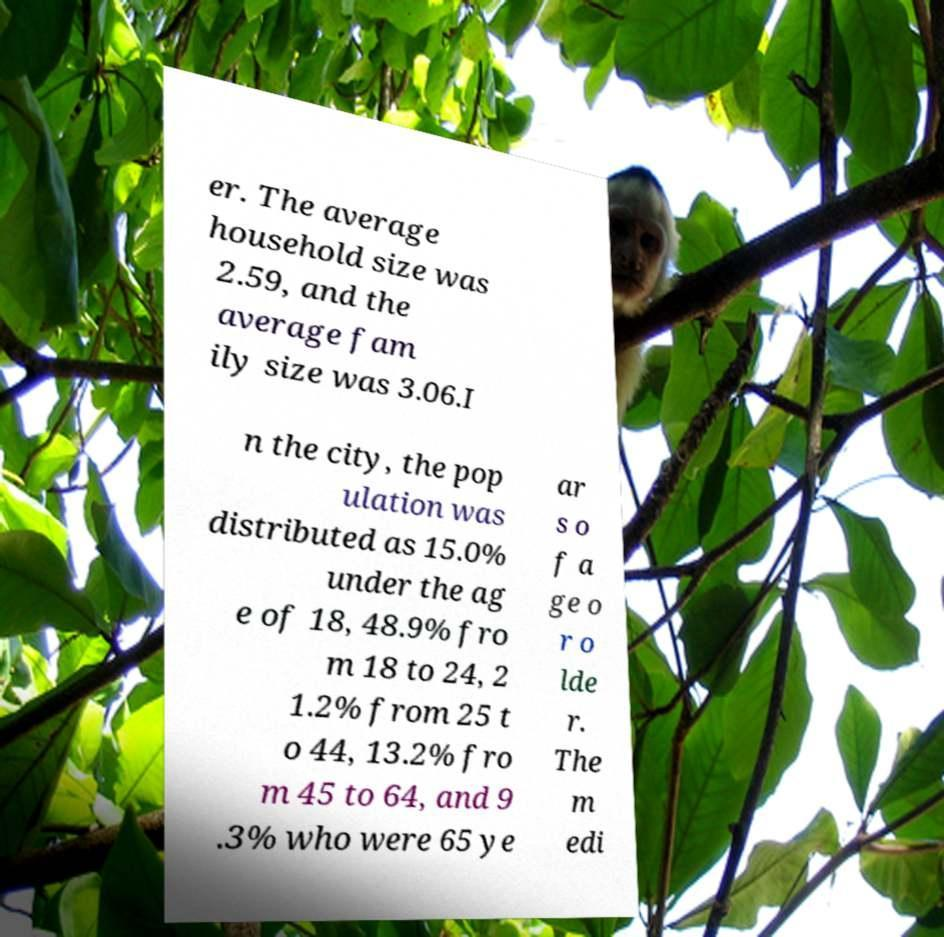There's text embedded in this image that I need extracted. Can you transcribe it verbatim? er. The average household size was 2.59, and the average fam ily size was 3.06.I n the city, the pop ulation was distributed as 15.0% under the ag e of 18, 48.9% fro m 18 to 24, 2 1.2% from 25 t o 44, 13.2% fro m 45 to 64, and 9 .3% who were 65 ye ar s o f a ge o r o lde r. The m edi 